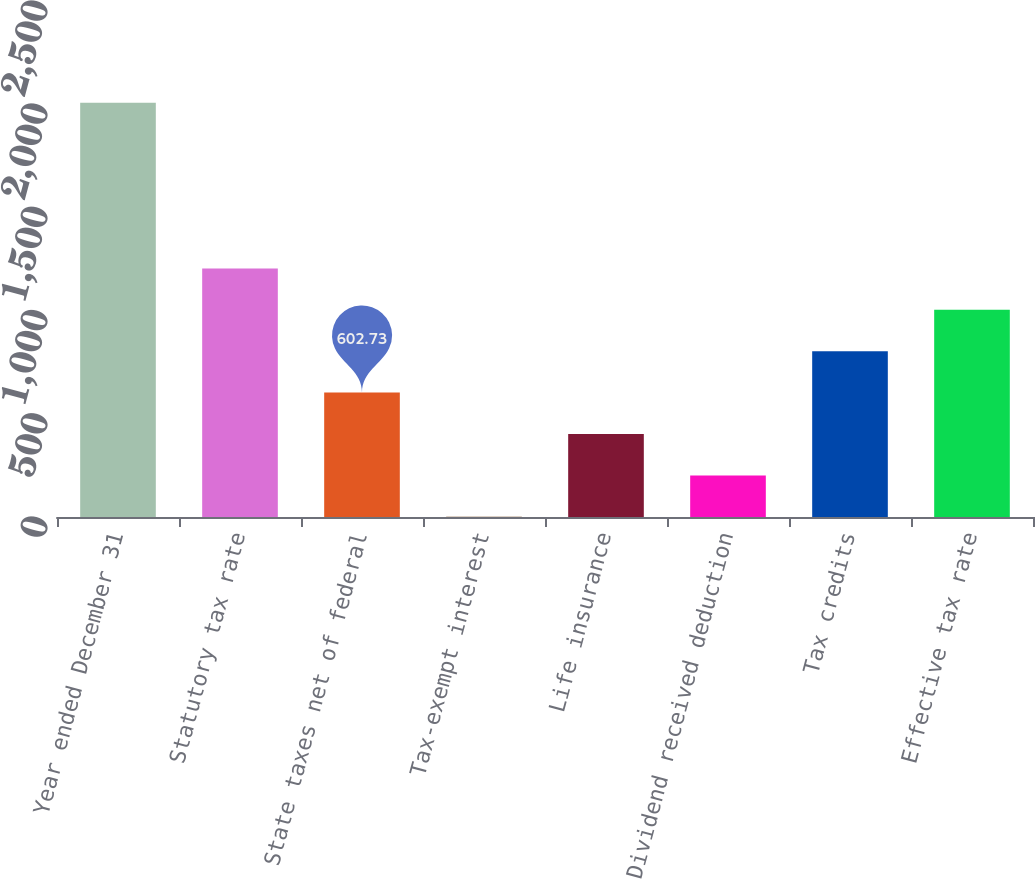Convert chart to OTSL. <chart><loc_0><loc_0><loc_500><loc_500><bar_chart><fcel>Year ended December 31<fcel>Statutory tax rate<fcel>State taxes net of federal<fcel>Tax-exempt interest<fcel>Life insurance<fcel>Dividend received deduction<fcel>Tax credits<fcel>Effective tax rate<nl><fcel>2007<fcel>1204.56<fcel>602.73<fcel>0.9<fcel>402.12<fcel>201.51<fcel>803.34<fcel>1003.95<nl></chart> 